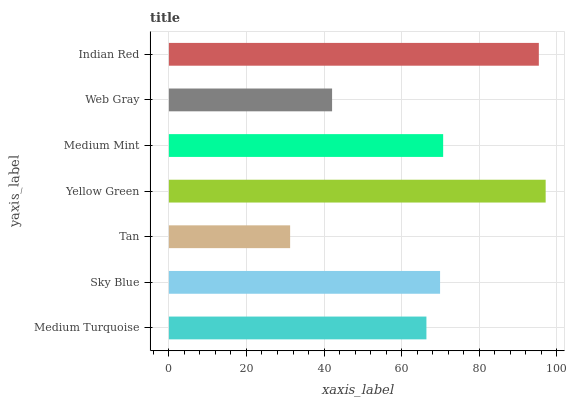Is Tan the minimum?
Answer yes or no. Yes. Is Yellow Green the maximum?
Answer yes or no. Yes. Is Sky Blue the minimum?
Answer yes or no. No. Is Sky Blue the maximum?
Answer yes or no. No. Is Sky Blue greater than Medium Turquoise?
Answer yes or no. Yes. Is Medium Turquoise less than Sky Blue?
Answer yes or no. Yes. Is Medium Turquoise greater than Sky Blue?
Answer yes or no. No. Is Sky Blue less than Medium Turquoise?
Answer yes or no. No. Is Sky Blue the high median?
Answer yes or no. Yes. Is Sky Blue the low median?
Answer yes or no. Yes. Is Yellow Green the high median?
Answer yes or no. No. Is Tan the low median?
Answer yes or no. No. 